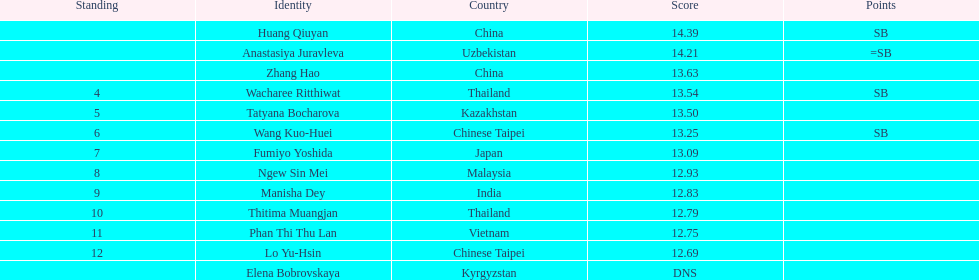How many points apart were the 1st place competitor and the 12th place competitor? 1.7. 